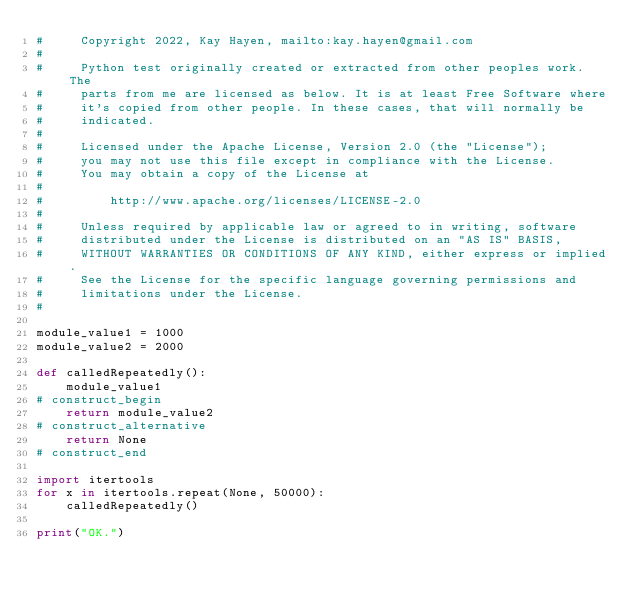Convert code to text. <code><loc_0><loc_0><loc_500><loc_500><_Python_>#     Copyright 2022, Kay Hayen, mailto:kay.hayen@gmail.com
#
#     Python test originally created or extracted from other peoples work. The
#     parts from me are licensed as below. It is at least Free Software where
#     it's copied from other people. In these cases, that will normally be
#     indicated.
#
#     Licensed under the Apache License, Version 2.0 (the "License");
#     you may not use this file except in compliance with the License.
#     You may obtain a copy of the License at
#
#         http://www.apache.org/licenses/LICENSE-2.0
#
#     Unless required by applicable law or agreed to in writing, software
#     distributed under the License is distributed on an "AS IS" BASIS,
#     WITHOUT WARRANTIES OR CONDITIONS OF ANY KIND, either express or implied.
#     See the License for the specific language governing permissions and
#     limitations under the License.
#

module_value1 = 1000
module_value2 = 2000

def calledRepeatedly():
    module_value1
# construct_begin
    return module_value2
# construct_alternative
    return None
# construct_end

import itertools
for x in itertools.repeat(None, 50000):
    calledRepeatedly()

print("OK.")
</code> 